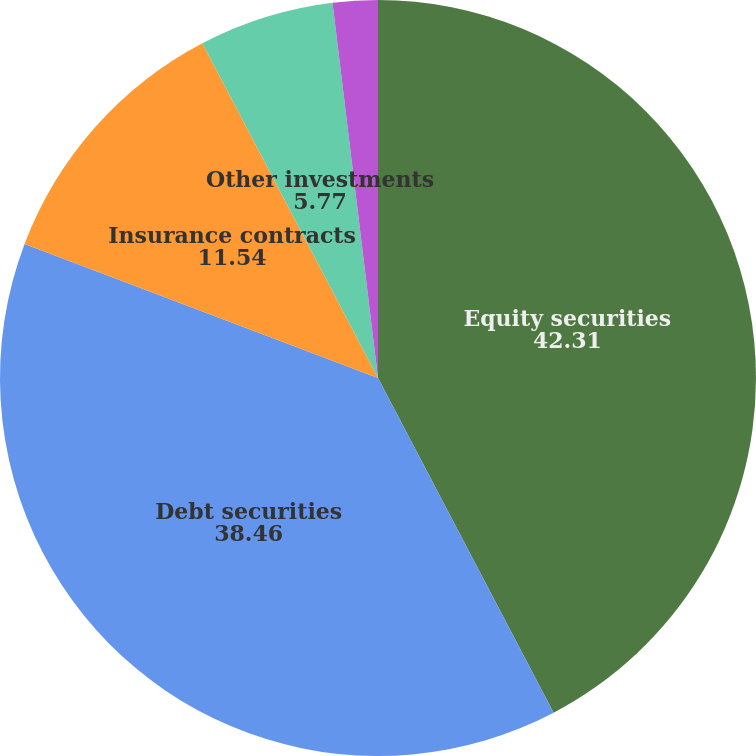Convert chart to OTSL. <chart><loc_0><loc_0><loc_500><loc_500><pie_chart><fcel>Equity securities<fcel>Debt securities<fcel>Insurance contracts<fcel>Other investments<fcel>Cash<nl><fcel>42.31%<fcel>38.46%<fcel>11.54%<fcel>5.77%<fcel>1.92%<nl></chart> 